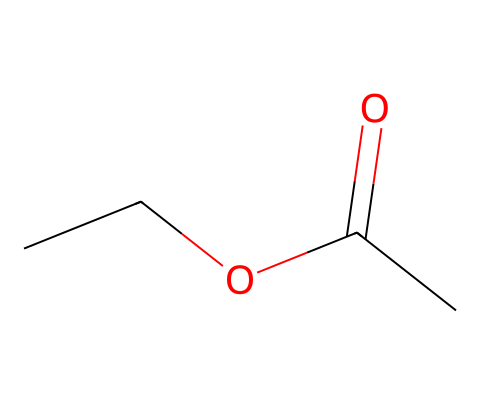What is the molecular formula of ethyl acetate? Ethyl acetate is represented by the SMILES notation CCOC(=O)C. By counting the carbon (C), hydrogen (H), and oxygen (O) atoms, we identify 4 carbons, 8 hydrogens, and 2 oxygens. Therefore, the molecular formula is C4H8O2.
Answer: C4H8O2 How many oxygen atoms are present in ethyl acetate? The SMILES structure shows two oxygen atoms in the "COC(=O)" part of the molecule. This segment indicates the presence of both an ether and a carbonyl group. Thus, there are 2 oxygen atoms.
Answer: 2 What type of functional group is present in ethyl acetate? The SMILES representation includes "C(=O)" which denotes a carbonyl group. Since ethyl acetate is an ester, it also contains an alkoxy group (the "CCO" part). Therefore, the functional group present is an ester.
Answer: ester What is the odor characteristic associated with ethyl acetate? Ethyl acetate is commonly known for its fruity smell, which is characteristic of many esters. This fruity aroma is prominent and often used in perfumes and flavorings.
Answer: fruity How many total hydrogen atoms are found in ethyl acetate? By analyzing the structure in the SMILES notation, we see that there are 8 hydrogen atoms connected to the carbons in the molecule. This includes those attached to the carbonyl carbon and the ethyl group. The count totals to 8.
Answer: 8 What type of isomerism can ethyl acetate display? Given its structure, ethyl acetate can exhibit cis-trans isomerism (geometric isomerism) due to the presence of a double bond between carbon and oxygen. However, it's more commonly analyzed for structural isomerism with related compounds.
Answer: structural isomerism 